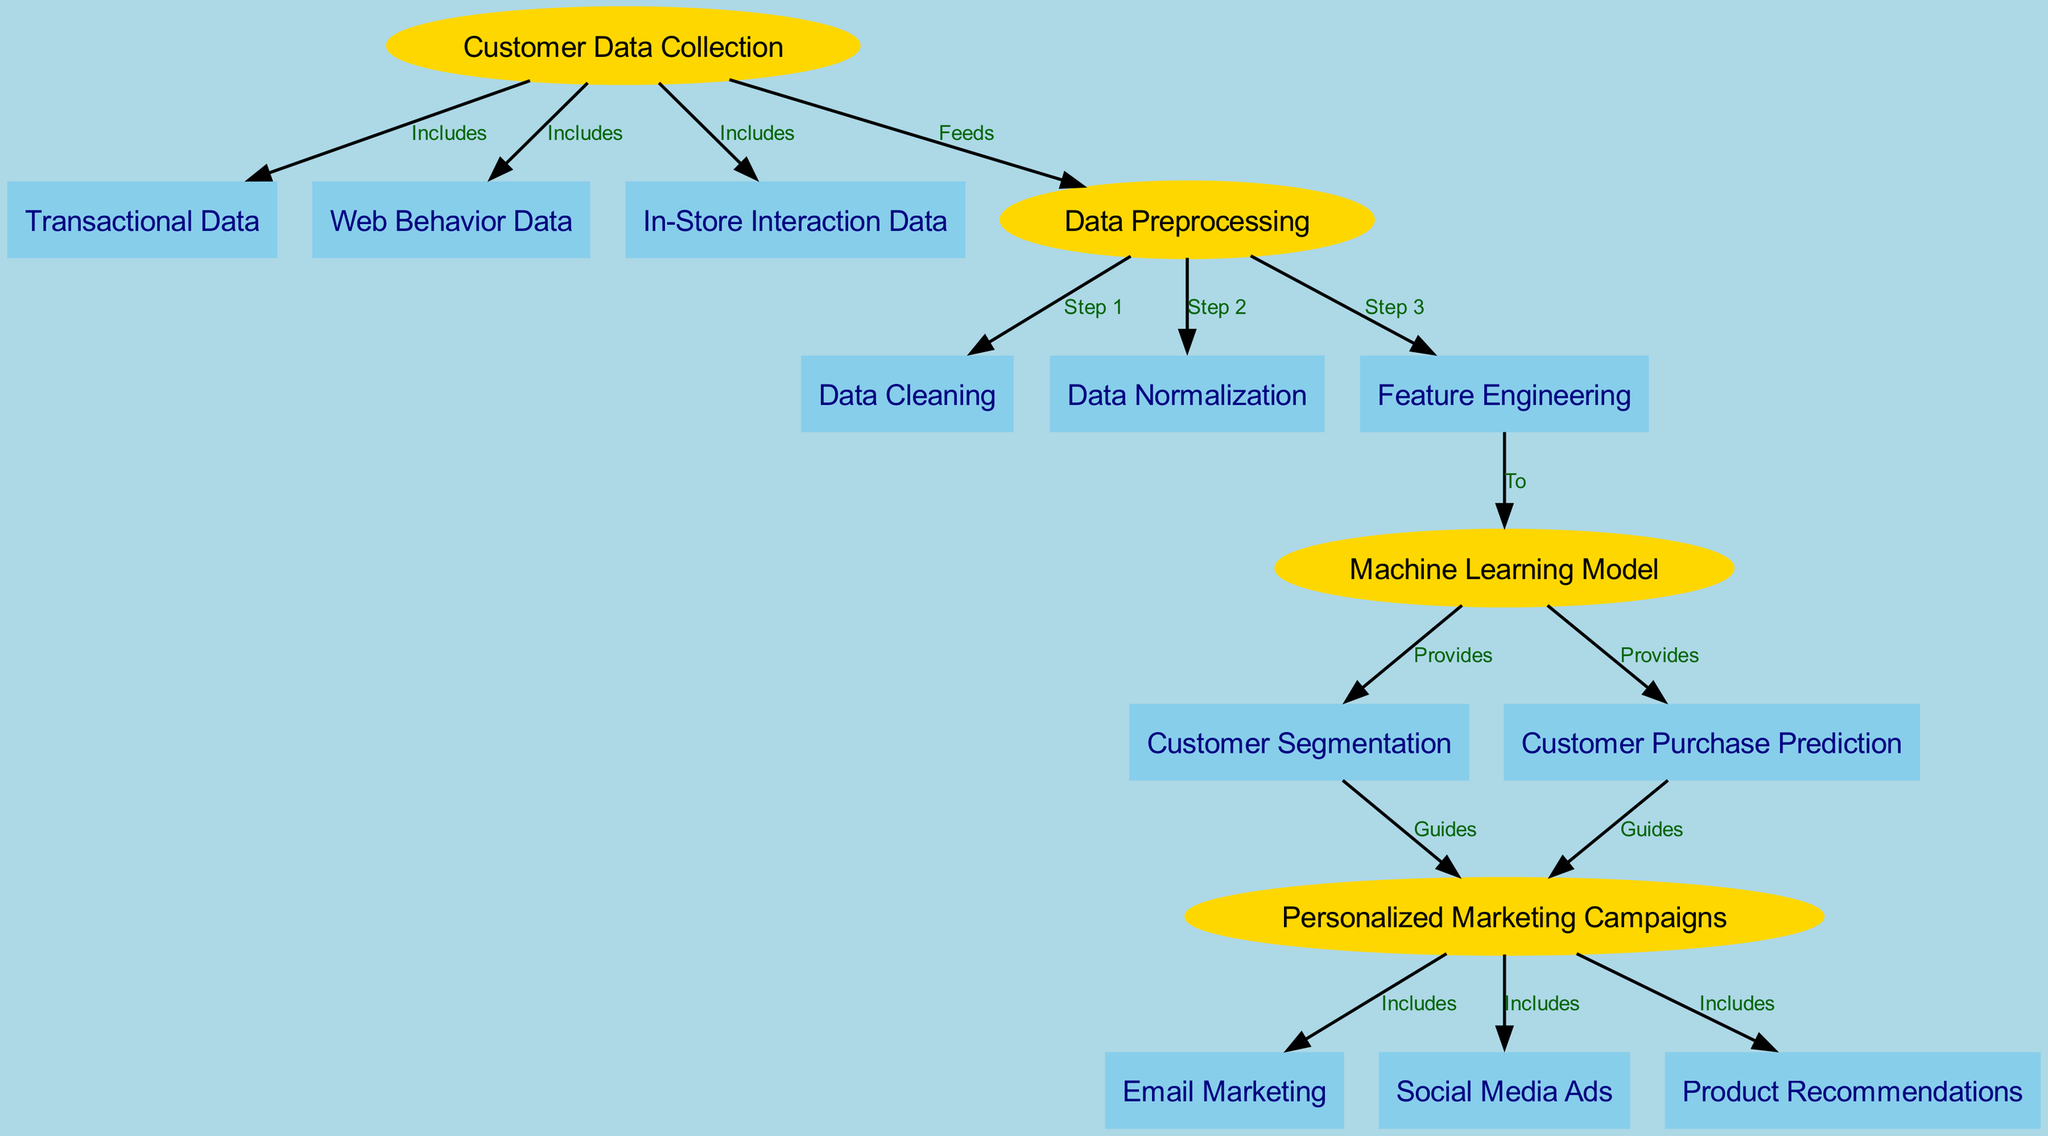What are the three types of data included in customer data collection? The diagram shows three data types connected to the "Customer Data Collection" node: "Transactional Data", "Web Behavior Data", and "In-Store Interaction Data".
Answer: Transactional Data, Web Behavior Data, In-Store Interaction Data How many preprocessing steps are there in the data preprocessing phase? The diagram indicates three specific steps within the "Data Preprocessing" node, labeled as Step 1, Step 2, and Step 3 (Data Cleaning, Data Normalization, and Feature Engineering).
Answer: 3 What type of analysis does the Machine Learning Model provide? According to the diagram, the "Machine Learning Model" node has two outgoing edges that indicate it provides "Customer Segmentation" and "Customer Purchase Prediction".
Answer: Customer Segmentation, Customer Purchase Prediction Which node guides the personalized marketing campaigns? The diagram shows that both the "Customer Segmentation" and "Customer Purchase Prediction" nodes guide the "Personalized Marketing Campaigns" node, indicating they influence the campaign planning.
Answer: Customer Segmentation, Customer Purchase Prediction Name one type of outreach included in personalized marketing campaigns. The diagram shows that the "Personalized Marketing Campaigns" node includes "Email Marketing", "Social Media Ads", and "Product Recommendations". Thus, any of these can be the answer.
Answer: Email Marketing What is the direct relationship between Data Normalization and Feature Engineering? In the diagram, "Data Normalization" is identified as Step 2 and has a direct connection to "Feature Engineering", categorized as Step 3 under the "Data Preprocessing". This indicates that normalization precedes feature engineering in the workflow.
Answer: Step 3 How many nodes describe types of marketing included in the personalized marketing campaigns? There are three nodes directly connected to "Personalized Marketing Campaigns" indicating different types of marketing: "Email Marketing", "Social Media Ads", and "Product Recommendations".
Answer: 3 Which data type feeds into Data Preprocessing? The diagram indicates that the "Customer Data Collection" feeds into the "Data Preprocessing", showcasing the workflow from raw data collection to preprocessing tasks.
Answer: Data Preprocessing 